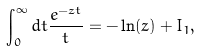Convert formula to latex. <formula><loc_0><loc_0><loc_500><loc_500>\int _ { 0 } ^ { \infty } d t \frac { e ^ { - z t } } { t } = - \ln ( z ) + I _ { 1 } ,</formula> 